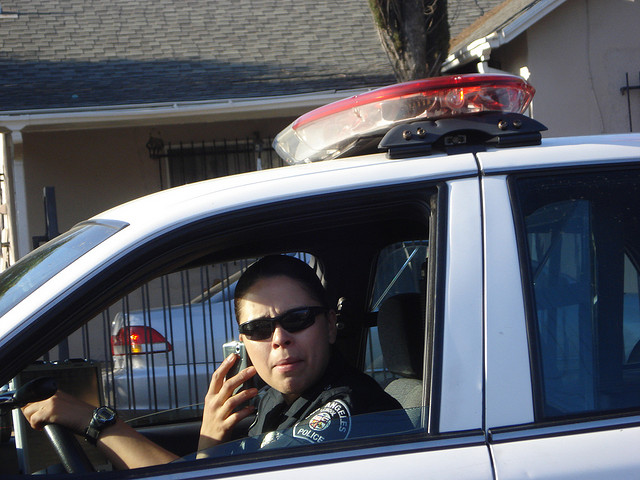Read and extract the text from this image. POLICE 